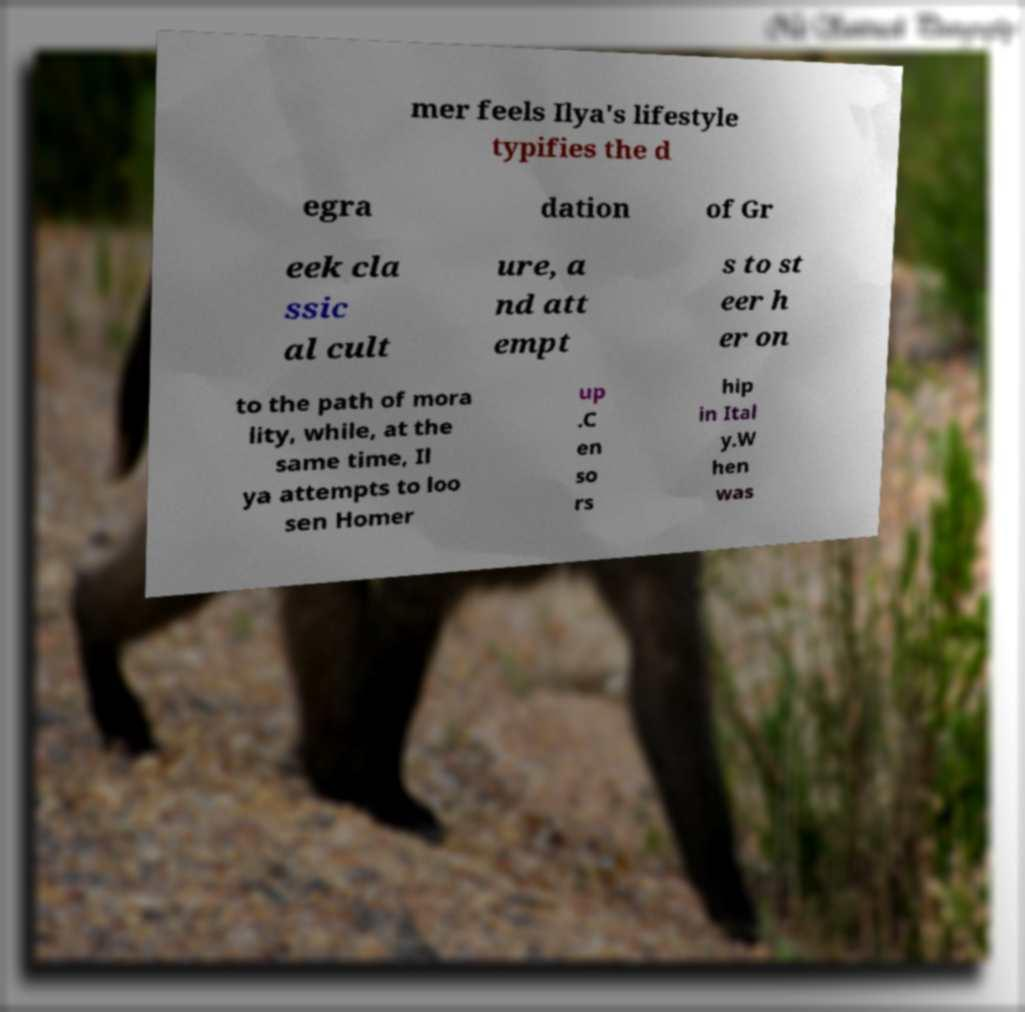Can you accurately transcribe the text from the provided image for me? mer feels Ilya's lifestyle typifies the d egra dation of Gr eek cla ssic al cult ure, a nd att empt s to st eer h er on to the path of mora lity, while, at the same time, Il ya attempts to loo sen Homer up .C en so rs hip in Ital y.W hen was 